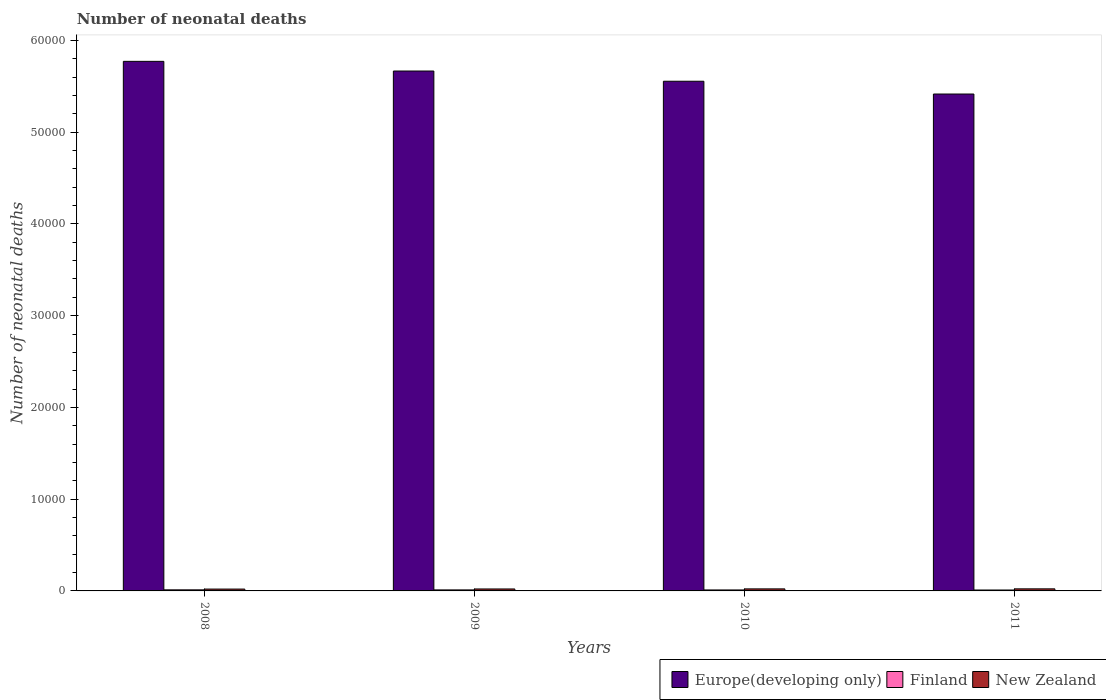Are the number of bars per tick equal to the number of legend labels?
Ensure brevity in your answer.  Yes. Are the number of bars on each tick of the X-axis equal?
Give a very brief answer. Yes. How many bars are there on the 2nd tick from the left?
Provide a succinct answer. 3. How many bars are there on the 1st tick from the right?
Give a very brief answer. 3. What is the label of the 1st group of bars from the left?
Give a very brief answer. 2008. In how many cases, is the number of bars for a given year not equal to the number of legend labels?
Keep it short and to the point. 0. What is the number of neonatal deaths in in Finland in 2011?
Ensure brevity in your answer.  99. Across all years, what is the maximum number of neonatal deaths in in Finland?
Provide a succinct answer. 118. Across all years, what is the minimum number of neonatal deaths in in Europe(developing only)?
Provide a short and direct response. 5.42e+04. In which year was the number of neonatal deaths in in New Zealand maximum?
Offer a terse response. 2011. What is the total number of neonatal deaths in in Finland in the graph?
Give a very brief answer. 435. What is the difference between the number of neonatal deaths in in New Zealand in 2008 and that in 2009?
Offer a terse response. -11. What is the difference between the number of neonatal deaths in in Finland in 2011 and the number of neonatal deaths in in New Zealand in 2009?
Offer a terse response. -114. What is the average number of neonatal deaths in in Finland per year?
Your answer should be very brief. 108.75. In the year 2008, what is the difference between the number of neonatal deaths in in Europe(developing only) and number of neonatal deaths in in Finland?
Your response must be concise. 5.76e+04. What is the ratio of the number of neonatal deaths in in Europe(developing only) in 2008 to that in 2011?
Your answer should be compact. 1.07. What is the difference between the highest and the lowest number of neonatal deaths in in Finland?
Provide a succinct answer. 19. In how many years, is the number of neonatal deaths in in Finland greater than the average number of neonatal deaths in in Finland taken over all years?
Offer a very short reply. 2. What does the 2nd bar from the left in 2008 represents?
Your answer should be compact. Finland. What does the 1st bar from the right in 2008 represents?
Provide a short and direct response. New Zealand. Is it the case that in every year, the sum of the number of neonatal deaths in in Europe(developing only) and number of neonatal deaths in in New Zealand is greater than the number of neonatal deaths in in Finland?
Provide a succinct answer. Yes. How many bars are there?
Ensure brevity in your answer.  12. Where does the legend appear in the graph?
Your answer should be compact. Bottom right. What is the title of the graph?
Provide a succinct answer. Number of neonatal deaths. What is the label or title of the X-axis?
Your answer should be very brief. Years. What is the label or title of the Y-axis?
Make the answer very short. Number of neonatal deaths. What is the Number of neonatal deaths in Europe(developing only) in 2008?
Provide a succinct answer. 5.77e+04. What is the Number of neonatal deaths of Finland in 2008?
Your answer should be compact. 118. What is the Number of neonatal deaths of New Zealand in 2008?
Provide a short and direct response. 202. What is the Number of neonatal deaths of Europe(developing only) in 2009?
Ensure brevity in your answer.  5.67e+04. What is the Number of neonatal deaths in Finland in 2009?
Provide a short and direct response. 112. What is the Number of neonatal deaths in New Zealand in 2009?
Your response must be concise. 213. What is the Number of neonatal deaths of Europe(developing only) in 2010?
Offer a terse response. 5.56e+04. What is the Number of neonatal deaths in Finland in 2010?
Your answer should be compact. 106. What is the Number of neonatal deaths of New Zealand in 2010?
Provide a short and direct response. 222. What is the Number of neonatal deaths in Europe(developing only) in 2011?
Ensure brevity in your answer.  5.42e+04. What is the Number of neonatal deaths of New Zealand in 2011?
Provide a short and direct response. 226. Across all years, what is the maximum Number of neonatal deaths in Europe(developing only)?
Offer a very short reply. 5.77e+04. Across all years, what is the maximum Number of neonatal deaths in Finland?
Ensure brevity in your answer.  118. Across all years, what is the maximum Number of neonatal deaths of New Zealand?
Give a very brief answer. 226. Across all years, what is the minimum Number of neonatal deaths of Europe(developing only)?
Ensure brevity in your answer.  5.42e+04. Across all years, what is the minimum Number of neonatal deaths of New Zealand?
Provide a short and direct response. 202. What is the total Number of neonatal deaths of Europe(developing only) in the graph?
Provide a short and direct response. 2.24e+05. What is the total Number of neonatal deaths of Finland in the graph?
Give a very brief answer. 435. What is the total Number of neonatal deaths in New Zealand in the graph?
Your answer should be compact. 863. What is the difference between the Number of neonatal deaths in Europe(developing only) in 2008 and that in 2009?
Make the answer very short. 1054. What is the difference between the Number of neonatal deaths in Finland in 2008 and that in 2009?
Your answer should be compact. 6. What is the difference between the Number of neonatal deaths of New Zealand in 2008 and that in 2009?
Give a very brief answer. -11. What is the difference between the Number of neonatal deaths in Europe(developing only) in 2008 and that in 2010?
Make the answer very short. 2168. What is the difference between the Number of neonatal deaths of Finland in 2008 and that in 2010?
Provide a short and direct response. 12. What is the difference between the Number of neonatal deaths of New Zealand in 2008 and that in 2010?
Provide a succinct answer. -20. What is the difference between the Number of neonatal deaths in Europe(developing only) in 2008 and that in 2011?
Provide a succinct answer. 3561. What is the difference between the Number of neonatal deaths of Finland in 2008 and that in 2011?
Your answer should be compact. 19. What is the difference between the Number of neonatal deaths in New Zealand in 2008 and that in 2011?
Provide a short and direct response. -24. What is the difference between the Number of neonatal deaths in Europe(developing only) in 2009 and that in 2010?
Give a very brief answer. 1114. What is the difference between the Number of neonatal deaths of New Zealand in 2009 and that in 2010?
Your answer should be very brief. -9. What is the difference between the Number of neonatal deaths in Europe(developing only) in 2009 and that in 2011?
Make the answer very short. 2507. What is the difference between the Number of neonatal deaths of Finland in 2009 and that in 2011?
Provide a short and direct response. 13. What is the difference between the Number of neonatal deaths in New Zealand in 2009 and that in 2011?
Provide a succinct answer. -13. What is the difference between the Number of neonatal deaths in Europe(developing only) in 2010 and that in 2011?
Your answer should be compact. 1393. What is the difference between the Number of neonatal deaths of New Zealand in 2010 and that in 2011?
Provide a short and direct response. -4. What is the difference between the Number of neonatal deaths in Europe(developing only) in 2008 and the Number of neonatal deaths in Finland in 2009?
Your answer should be very brief. 5.76e+04. What is the difference between the Number of neonatal deaths of Europe(developing only) in 2008 and the Number of neonatal deaths of New Zealand in 2009?
Ensure brevity in your answer.  5.75e+04. What is the difference between the Number of neonatal deaths of Finland in 2008 and the Number of neonatal deaths of New Zealand in 2009?
Your answer should be compact. -95. What is the difference between the Number of neonatal deaths of Europe(developing only) in 2008 and the Number of neonatal deaths of Finland in 2010?
Provide a short and direct response. 5.76e+04. What is the difference between the Number of neonatal deaths in Europe(developing only) in 2008 and the Number of neonatal deaths in New Zealand in 2010?
Provide a succinct answer. 5.75e+04. What is the difference between the Number of neonatal deaths in Finland in 2008 and the Number of neonatal deaths in New Zealand in 2010?
Offer a very short reply. -104. What is the difference between the Number of neonatal deaths of Europe(developing only) in 2008 and the Number of neonatal deaths of Finland in 2011?
Provide a short and direct response. 5.76e+04. What is the difference between the Number of neonatal deaths of Europe(developing only) in 2008 and the Number of neonatal deaths of New Zealand in 2011?
Provide a succinct answer. 5.75e+04. What is the difference between the Number of neonatal deaths of Finland in 2008 and the Number of neonatal deaths of New Zealand in 2011?
Provide a short and direct response. -108. What is the difference between the Number of neonatal deaths of Europe(developing only) in 2009 and the Number of neonatal deaths of Finland in 2010?
Ensure brevity in your answer.  5.66e+04. What is the difference between the Number of neonatal deaths of Europe(developing only) in 2009 and the Number of neonatal deaths of New Zealand in 2010?
Offer a very short reply. 5.64e+04. What is the difference between the Number of neonatal deaths in Finland in 2009 and the Number of neonatal deaths in New Zealand in 2010?
Keep it short and to the point. -110. What is the difference between the Number of neonatal deaths of Europe(developing only) in 2009 and the Number of neonatal deaths of Finland in 2011?
Keep it short and to the point. 5.66e+04. What is the difference between the Number of neonatal deaths in Europe(developing only) in 2009 and the Number of neonatal deaths in New Zealand in 2011?
Your answer should be compact. 5.64e+04. What is the difference between the Number of neonatal deaths in Finland in 2009 and the Number of neonatal deaths in New Zealand in 2011?
Keep it short and to the point. -114. What is the difference between the Number of neonatal deaths of Europe(developing only) in 2010 and the Number of neonatal deaths of Finland in 2011?
Your answer should be very brief. 5.55e+04. What is the difference between the Number of neonatal deaths of Europe(developing only) in 2010 and the Number of neonatal deaths of New Zealand in 2011?
Provide a short and direct response. 5.53e+04. What is the difference between the Number of neonatal deaths in Finland in 2010 and the Number of neonatal deaths in New Zealand in 2011?
Keep it short and to the point. -120. What is the average Number of neonatal deaths in Europe(developing only) per year?
Ensure brevity in your answer.  5.60e+04. What is the average Number of neonatal deaths in Finland per year?
Provide a short and direct response. 108.75. What is the average Number of neonatal deaths of New Zealand per year?
Provide a short and direct response. 215.75. In the year 2008, what is the difference between the Number of neonatal deaths of Europe(developing only) and Number of neonatal deaths of Finland?
Ensure brevity in your answer.  5.76e+04. In the year 2008, what is the difference between the Number of neonatal deaths of Europe(developing only) and Number of neonatal deaths of New Zealand?
Keep it short and to the point. 5.75e+04. In the year 2008, what is the difference between the Number of neonatal deaths of Finland and Number of neonatal deaths of New Zealand?
Your response must be concise. -84. In the year 2009, what is the difference between the Number of neonatal deaths in Europe(developing only) and Number of neonatal deaths in Finland?
Your answer should be compact. 5.66e+04. In the year 2009, what is the difference between the Number of neonatal deaths of Europe(developing only) and Number of neonatal deaths of New Zealand?
Make the answer very short. 5.65e+04. In the year 2009, what is the difference between the Number of neonatal deaths in Finland and Number of neonatal deaths in New Zealand?
Make the answer very short. -101. In the year 2010, what is the difference between the Number of neonatal deaths in Europe(developing only) and Number of neonatal deaths in Finland?
Ensure brevity in your answer.  5.54e+04. In the year 2010, what is the difference between the Number of neonatal deaths in Europe(developing only) and Number of neonatal deaths in New Zealand?
Give a very brief answer. 5.53e+04. In the year 2010, what is the difference between the Number of neonatal deaths of Finland and Number of neonatal deaths of New Zealand?
Your answer should be very brief. -116. In the year 2011, what is the difference between the Number of neonatal deaths in Europe(developing only) and Number of neonatal deaths in Finland?
Your answer should be very brief. 5.41e+04. In the year 2011, what is the difference between the Number of neonatal deaths in Europe(developing only) and Number of neonatal deaths in New Zealand?
Offer a very short reply. 5.39e+04. In the year 2011, what is the difference between the Number of neonatal deaths in Finland and Number of neonatal deaths in New Zealand?
Provide a succinct answer. -127. What is the ratio of the Number of neonatal deaths of Europe(developing only) in 2008 to that in 2009?
Ensure brevity in your answer.  1.02. What is the ratio of the Number of neonatal deaths of Finland in 2008 to that in 2009?
Your answer should be compact. 1.05. What is the ratio of the Number of neonatal deaths of New Zealand in 2008 to that in 2009?
Your answer should be compact. 0.95. What is the ratio of the Number of neonatal deaths of Europe(developing only) in 2008 to that in 2010?
Your answer should be very brief. 1.04. What is the ratio of the Number of neonatal deaths of Finland in 2008 to that in 2010?
Offer a very short reply. 1.11. What is the ratio of the Number of neonatal deaths in New Zealand in 2008 to that in 2010?
Make the answer very short. 0.91. What is the ratio of the Number of neonatal deaths in Europe(developing only) in 2008 to that in 2011?
Your answer should be very brief. 1.07. What is the ratio of the Number of neonatal deaths of Finland in 2008 to that in 2011?
Provide a succinct answer. 1.19. What is the ratio of the Number of neonatal deaths in New Zealand in 2008 to that in 2011?
Offer a very short reply. 0.89. What is the ratio of the Number of neonatal deaths of Europe(developing only) in 2009 to that in 2010?
Your answer should be compact. 1.02. What is the ratio of the Number of neonatal deaths of Finland in 2009 to that in 2010?
Your answer should be very brief. 1.06. What is the ratio of the Number of neonatal deaths of New Zealand in 2009 to that in 2010?
Offer a very short reply. 0.96. What is the ratio of the Number of neonatal deaths of Europe(developing only) in 2009 to that in 2011?
Provide a succinct answer. 1.05. What is the ratio of the Number of neonatal deaths in Finland in 2009 to that in 2011?
Make the answer very short. 1.13. What is the ratio of the Number of neonatal deaths of New Zealand in 2009 to that in 2011?
Offer a terse response. 0.94. What is the ratio of the Number of neonatal deaths of Europe(developing only) in 2010 to that in 2011?
Your answer should be very brief. 1.03. What is the ratio of the Number of neonatal deaths of Finland in 2010 to that in 2011?
Your response must be concise. 1.07. What is the ratio of the Number of neonatal deaths of New Zealand in 2010 to that in 2011?
Give a very brief answer. 0.98. What is the difference between the highest and the second highest Number of neonatal deaths of Europe(developing only)?
Your response must be concise. 1054. What is the difference between the highest and the second highest Number of neonatal deaths of Finland?
Provide a short and direct response. 6. What is the difference between the highest and the lowest Number of neonatal deaths of Europe(developing only)?
Keep it short and to the point. 3561. What is the difference between the highest and the lowest Number of neonatal deaths of Finland?
Make the answer very short. 19. 